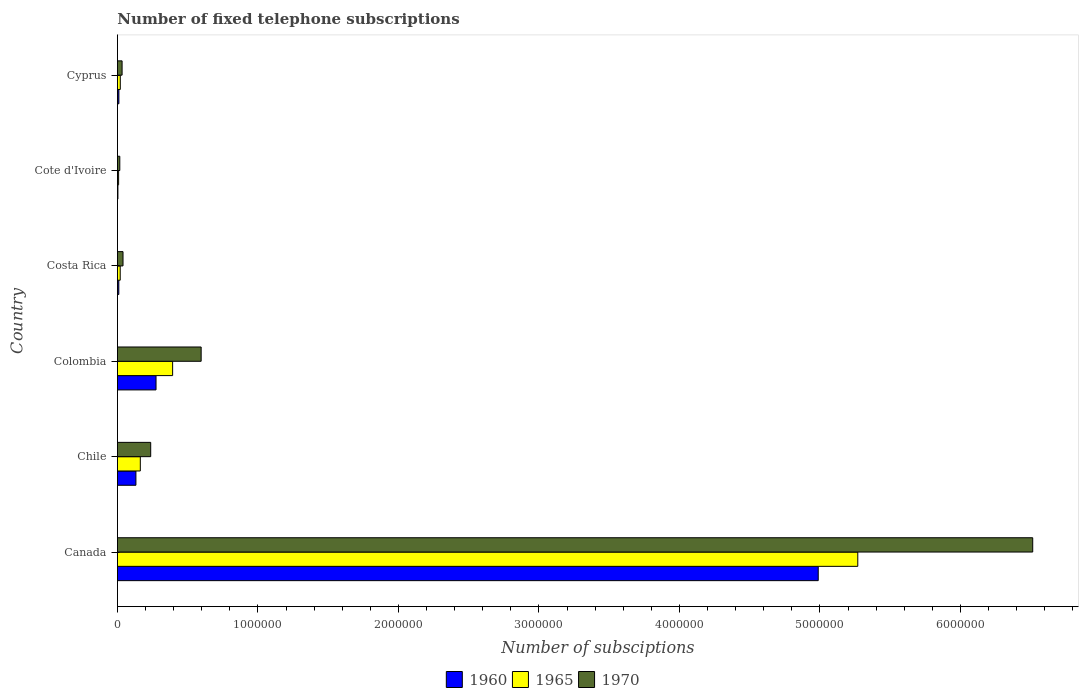How many different coloured bars are there?
Keep it short and to the point. 3. Are the number of bars per tick equal to the number of legend labels?
Keep it short and to the point. Yes. Are the number of bars on each tick of the Y-axis equal?
Your answer should be compact. Yes. In how many cases, is the number of bars for a given country not equal to the number of legend labels?
Your answer should be compact. 0. What is the number of fixed telephone subscriptions in 1965 in Colombia?
Provide a succinct answer. 3.93e+05. Across all countries, what is the maximum number of fixed telephone subscriptions in 1960?
Offer a very short reply. 4.99e+06. Across all countries, what is the minimum number of fixed telephone subscriptions in 1960?
Offer a very short reply. 3690. In which country was the number of fixed telephone subscriptions in 1960 maximum?
Your answer should be very brief. Canada. In which country was the number of fixed telephone subscriptions in 1960 minimum?
Provide a short and direct response. Cote d'Ivoire. What is the total number of fixed telephone subscriptions in 1970 in the graph?
Give a very brief answer. 7.44e+06. What is the difference between the number of fixed telephone subscriptions in 1970 in Costa Rica and that in Cyprus?
Offer a very short reply. 6641. What is the difference between the number of fixed telephone subscriptions in 1960 in Canada and the number of fixed telephone subscriptions in 1965 in Chile?
Make the answer very short. 4.82e+06. What is the average number of fixed telephone subscriptions in 1965 per country?
Offer a terse response. 9.79e+05. What is the difference between the number of fixed telephone subscriptions in 1965 and number of fixed telephone subscriptions in 1960 in Chile?
Offer a terse response. 3.12e+04. In how many countries, is the number of fixed telephone subscriptions in 1970 greater than 2400000 ?
Offer a terse response. 1. What is the ratio of the number of fixed telephone subscriptions in 1970 in Chile to that in Colombia?
Your response must be concise. 0.4. Is the difference between the number of fixed telephone subscriptions in 1965 in Canada and Cyprus greater than the difference between the number of fixed telephone subscriptions in 1960 in Canada and Cyprus?
Ensure brevity in your answer.  Yes. What is the difference between the highest and the second highest number of fixed telephone subscriptions in 1970?
Provide a succinct answer. 5.92e+06. What is the difference between the highest and the lowest number of fixed telephone subscriptions in 1970?
Ensure brevity in your answer.  6.50e+06. What does the 2nd bar from the top in Cote d'Ivoire represents?
Your answer should be very brief. 1965. How many bars are there?
Offer a terse response. 18. Are all the bars in the graph horizontal?
Give a very brief answer. Yes. How many countries are there in the graph?
Offer a terse response. 6. What is the difference between two consecutive major ticks on the X-axis?
Ensure brevity in your answer.  1.00e+06. Are the values on the major ticks of X-axis written in scientific E-notation?
Your response must be concise. No. Does the graph contain any zero values?
Keep it short and to the point. No. How many legend labels are there?
Offer a very short reply. 3. How are the legend labels stacked?
Your answer should be very brief. Horizontal. What is the title of the graph?
Provide a short and direct response. Number of fixed telephone subscriptions. Does "2012" appear as one of the legend labels in the graph?
Make the answer very short. No. What is the label or title of the X-axis?
Your response must be concise. Number of subsciptions. What is the label or title of the Y-axis?
Offer a terse response. Country. What is the Number of subsciptions of 1960 in Canada?
Ensure brevity in your answer.  4.99e+06. What is the Number of subsciptions of 1965 in Canada?
Keep it short and to the point. 5.27e+06. What is the Number of subsciptions in 1970 in Canada?
Offer a terse response. 6.51e+06. What is the Number of subsciptions in 1960 in Chile?
Offer a very short reply. 1.32e+05. What is the Number of subsciptions in 1965 in Chile?
Provide a succinct answer. 1.63e+05. What is the Number of subsciptions in 1970 in Chile?
Provide a succinct answer. 2.37e+05. What is the Number of subsciptions of 1960 in Colombia?
Offer a terse response. 2.75e+05. What is the Number of subsciptions of 1965 in Colombia?
Keep it short and to the point. 3.93e+05. What is the Number of subsciptions in 1970 in Colombia?
Offer a terse response. 5.96e+05. What is the Number of subsciptions of 1960 in Costa Rica?
Your answer should be very brief. 10000. What is the Number of subsciptions of 1970 in Costa Rica?
Give a very brief answer. 4.00e+04. What is the Number of subsciptions of 1960 in Cote d'Ivoire?
Make the answer very short. 3690. What is the Number of subsciptions in 1965 in Cote d'Ivoire?
Your answer should be compact. 8600. What is the Number of subsciptions in 1970 in Cote d'Ivoire?
Provide a short and direct response. 1.70e+04. What is the Number of subsciptions in 1960 in Cyprus?
Offer a terse response. 1.06e+04. What is the Number of subsciptions of 1965 in Cyprus?
Offer a terse response. 2.06e+04. What is the Number of subsciptions of 1970 in Cyprus?
Give a very brief answer. 3.34e+04. Across all countries, what is the maximum Number of subsciptions of 1960?
Offer a terse response. 4.99e+06. Across all countries, what is the maximum Number of subsciptions of 1965?
Ensure brevity in your answer.  5.27e+06. Across all countries, what is the maximum Number of subsciptions of 1970?
Your answer should be very brief. 6.51e+06. Across all countries, what is the minimum Number of subsciptions in 1960?
Keep it short and to the point. 3690. Across all countries, what is the minimum Number of subsciptions in 1965?
Offer a very short reply. 8600. Across all countries, what is the minimum Number of subsciptions of 1970?
Your answer should be very brief. 1.70e+04. What is the total Number of subsciptions in 1960 in the graph?
Your response must be concise. 5.42e+06. What is the total Number of subsciptions in 1965 in the graph?
Make the answer very short. 5.87e+06. What is the total Number of subsciptions of 1970 in the graph?
Offer a very short reply. 7.44e+06. What is the difference between the Number of subsciptions in 1960 in Canada and that in Chile?
Keep it short and to the point. 4.86e+06. What is the difference between the Number of subsciptions of 1965 in Canada and that in Chile?
Your answer should be very brief. 5.11e+06. What is the difference between the Number of subsciptions of 1970 in Canada and that in Chile?
Ensure brevity in your answer.  6.28e+06. What is the difference between the Number of subsciptions of 1960 in Canada and that in Colombia?
Offer a very short reply. 4.71e+06. What is the difference between the Number of subsciptions of 1965 in Canada and that in Colombia?
Ensure brevity in your answer.  4.88e+06. What is the difference between the Number of subsciptions in 1970 in Canada and that in Colombia?
Offer a very short reply. 5.92e+06. What is the difference between the Number of subsciptions in 1960 in Canada and that in Costa Rica?
Offer a terse response. 4.98e+06. What is the difference between the Number of subsciptions of 1965 in Canada and that in Costa Rica?
Give a very brief answer. 5.25e+06. What is the difference between the Number of subsciptions of 1970 in Canada and that in Costa Rica?
Make the answer very short. 6.47e+06. What is the difference between the Number of subsciptions of 1960 in Canada and that in Cote d'Ivoire?
Provide a succinct answer. 4.98e+06. What is the difference between the Number of subsciptions of 1965 in Canada and that in Cote d'Ivoire?
Give a very brief answer. 5.26e+06. What is the difference between the Number of subsciptions in 1970 in Canada and that in Cote d'Ivoire?
Your answer should be compact. 6.50e+06. What is the difference between the Number of subsciptions of 1960 in Canada and that in Cyprus?
Ensure brevity in your answer.  4.98e+06. What is the difference between the Number of subsciptions of 1965 in Canada and that in Cyprus?
Your answer should be very brief. 5.25e+06. What is the difference between the Number of subsciptions in 1970 in Canada and that in Cyprus?
Your response must be concise. 6.48e+06. What is the difference between the Number of subsciptions of 1960 in Chile and that in Colombia?
Your answer should be very brief. -1.43e+05. What is the difference between the Number of subsciptions of 1970 in Chile and that in Colombia?
Make the answer very short. -3.59e+05. What is the difference between the Number of subsciptions of 1960 in Chile and that in Costa Rica?
Offer a terse response. 1.22e+05. What is the difference between the Number of subsciptions in 1965 in Chile and that in Costa Rica?
Give a very brief answer. 1.43e+05. What is the difference between the Number of subsciptions of 1970 in Chile and that in Costa Rica?
Provide a short and direct response. 1.97e+05. What is the difference between the Number of subsciptions of 1960 in Chile and that in Cote d'Ivoire?
Provide a succinct answer. 1.28e+05. What is the difference between the Number of subsciptions in 1965 in Chile and that in Cote d'Ivoire?
Keep it short and to the point. 1.54e+05. What is the difference between the Number of subsciptions in 1970 in Chile and that in Cote d'Ivoire?
Provide a short and direct response. 2.20e+05. What is the difference between the Number of subsciptions of 1960 in Chile and that in Cyprus?
Keep it short and to the point. 1.21e+05. What is the difference between the Number of subsciptions in 1965 in Chile and that in Cyprus?
Provide a succinct answer. 1.42e+05. What is the difference between the Number of subsciptions of 1970 in Chile and that in Cyprus?
Give a very brief answer. 2.04e+05. What is the difference between the Number of subsciptions of 1960 in Colombia and that in Costa Rica?
Your answer should be compact. 2.65e+05. What is the difference between the Number of subsciptions of 1965 in Colombia and that in Costa Rica?
Ensure brevity in your answer.  3.73e+05. What is the difference between the Number of subsciptions in 1970 in Colombia and that in Costa Rica?
Offer a very short reply. 5.56e+05. What is the difference between the Number of subsciptions in 1960 in Colombia and that in Cote d'Ivoire?
Your answer should be very brief. 2.71e+05. What is the difference between the Number of subsciptions of 1965 in Colombia and that in Cote d'Ivoire?
Give a very brief answer. 3.84e+05. What is the difference between the Number of subsciptions in 1970 in Colombia and that in Cote d'Ivoire?
Offer a terse response. 5.79e+05. What is the difference between the Number of subsciptions in 1960 in Colombia and that in Cyprus?
Your answer should be very brief. 2.64e+05. What is the difference between the Number of subsciptions of 1965 in Colombia and that in Cyprus?
Offer a terse response. 3.72e+05. What is the difference between the Number of subsciptions of 1970 in Colombia and that in Cyprus?
Your response must be concise. 5.63e+05. What is the difference between the Number of subsciptions in 1960 in Costa Rica and that in Cote d'Ivoire?
Keep it short and to the point. 6310. What is the difference between the Number of subsciptions in 1965 in Costa Rica and that in Cote d'Ivoire?
Your answer should be very brief. 1.14e+04. What is the difference between the Number of subsciptions in 1970 in Costa Rica and that in Cote d'Ivoire?
Provide a succinct answer. 2.30e+04. What is the difference between the Number of subsciptions of 1960 in Costa Rica and that in Cyprus?
Provide a short and direct response. -630. What is the difference between the Number of subsciptions of 1965 in Costa Rica and that in Cyprus?
Give a very brief answer. -550. What is the difference between the Number of subsciptions in 1970 in Costa Rica and that in Cyprus?
Offer a very short reply. 6641. What is the difference between the Number of subsciptions of 1960 in Cote d'Ivoire and that in Cyprus?
Your answer should be very brief. -6940. What is the difference between the Number of subsciptions in 1965 in Cote d'Ivoire and that in Cyprus?
Offer a terse response. -1.20e+04. What is the difference between the Number of subsciptions in 1970 in Cote d'Ivoire and that in Cyprus?
Your answer should be very brief. -1.64e+04. What is the difference between the Number of subsciptions in 1960 in Canada and the Number of subsciptions in 1965 in Chile?
Provide a short and direct response. 4.82e+06. What is the difference between the Number of subsciptions in 1960 in Canada and the Number of subsciptions in 1970 in Chile?
Ensure brevity in your answer.  4.75e+06. What is the difference between the Number of subsciptions in 1965 in Canada and the Number of subsciptions in 1970 in Chile?
Provide a succinct answer. 5.03e+06. What is the difference between the Number of subsciptions of 1960 in Canada and the Number of subsciptions of 1965 in Colombia?
Your response must be concise. 4.59e+06. What is the difference between the Number of subsciptions in 1960 in Canada and the Number of subsciptions in 1970 in Colombia?
Provide a short and direct response. 4.39e+06. What is the difference between the Number of subsciptions in 1965 in Canada and the Number of subsciptions in 1970 in Colombia?
Make the answer very short. 4.67e+06. What is the difference between the Number of subsciptions of 1960 in Canada and the Number of subsciptions of 1965 in Costa Rica?
Ensure brevity in your answer.  4.97e+06. What is the difference between the Number of subsciptions of 1960 in Canada and the Number of subsciptions of 1970 in Costa Rica?
Ensure brevity in your answer.  4.95e+06. What is the difference between the Number of subsciptions in 1965 in Canada and the Number of subsciptions in 1970 in Costa Rica?
Make the answer very short. 5.23e+06. What is the difference between the Number of subsciptions of 1960 in Canada and the Number of subsciptions of 1965 in Cote d'Ivoire?
Keep it short and to the point. 4.98e+06. What is the difference between the Number of subsciptions of 1960 in Canada and the Number of subsciptions of 1970 in Cote d'Ivoire?
Provide a short and direct response. 4.97e+06. What is the difference between the Number of subsciptions of 1965 in Canada and the Number of subsciptions of 1970 in Cote d'Ivoire?
Provide a succinct answer. 5.25e+06. What is the difference between the Number of subsciptions of 1960 in Canada and the Number of subsciptions of 1965 in Cyprus?
Provide a short and direct response. 4.97e+06. What is the difference between the Number of subsciptions of 1960 in Canada and the Number of subsciptions of 1970 in Cyprus?
Provide a short and direct response. 4.95e+06. What is the difference between the Number of subsciptions in 1965 in Canada and the Number of subsciptions in 1970 in Cyprus?
Make the answer very short. 5.24e+06. What is the difference between the Number of subsciptions of 1960 in Chile and the Number of subsciptions of 1965 in Colombia?
Keep it short and to the point. -2.61e+05. What is the difference between the Number of subsciptions in 1960 in Chile and the Number of subsciptions in 1970 in Colombia?
Give a very brief answer. -4.64e+05. What is the difference between the Number of subsciptions of 1965 in Chile and the Number of subsciptions of 1970 in Colombia?
Provide a succinct answer. -4.33e+05. What is the difference between the Number of subsciptions of 1960 in Chile and the Number of subsciptions of 1965 in Costa Rica?
Ensure brevity in your answer.  1.12e+05. What is the difference between the Number of subsciptions of 1960 in Chile and the Number of subsciptions of 1970 in Costa Rica?
Your response must be concise. 9.18e+04. What is the difference between the Number of subsciptions of 1965 in Chile and the Number of subsciptions of 1970 in Costa Rica?
Offer a very short reply. 1.23e+05. What is the difference between the Number of subsciptions of 1960 in Chile and the Number of subsciptions of 1965 in Cote d'Ivoire?
Provide a succinct answer. 1.23e+05. What is the difference between the Number of subsciptions of 1960 in Chile and the Number of subsciptions of 1970 in Cote d'Ivoire?
Provide a succinct answer. 1.15e+05. What is the difference between the Number of subsciptions in 1965 in Chile and the Number of subsciptions in 1970 in Cote d'Ivoire?
Your answer should be compact. 1.46e+05. What is the difference between the Number of subsciptions of 1960 in Chile and the Number of subsciptions of 1965 in Cyprus?
Your response must be concise. 1.11e+05. What is the difference between the Number of subsciptions in 1960 in Chile and the Number of subsciptions in 1970 in Cyprus?
Provide a short and direct response. 9.84e+04. What is the difference between the Number of subsciptions in 1965 in Chile and the Number of subsciptions in 1970 in Cyprus?
Ensure brevity in your answer.  1.30e+05. What is the difference between the Number of subsciptions in 1960 in Colombia and the Number of subsciptions in 1965 in Costa Rica?
Offer a terse response. 2.55e+05. What is the difference between the Number of subsciptions in 1960 in Colombia and the Number of subsciptions in 1970 in Costa Rica?
Provide a short and direct response. 2.35e+05. What is the difference between the Number of subsciptions in 1965 in Colombia and the Number of subsciptions in 1970 in Costa Rica?
Make the answer very short. 3.53e+05. What is the difference between the Number of subsciptions of 1960 in Colombia and the Number of subsciptions of 1965 in Cote d'Ivoire?
Give a very brief answer. 2.66e+05. What is the difference between the Number of subsciptions of 1960 in Colombia and the Number of subsciptions of 1970 in Cote d'Ivoire?
Offer a terse response. 2.58e+05. What is the difference between the Number of subsciptions in 1965 in Colombia and the Number of subsciptions in 1970 in Cote d'Ivoire?
Provide a short and direct response. 3.76e+05. What is the difference between the Number of subsciptions in 1960 in Colombia and the Number of subsciptions in 1965 in Cyprus?
Offer a terse response. 2.54e+05. What is the difference between the Number of subsciptions of 1960 in Colombia and the Number of subsciptions of 1970 in Cyprus?
Offer a very short reply. 2.42e+05. What is the difference between the Number of subsciptions in 1965 in Colombia and the Number of subsciptions in 1970 in Cyprus?
Offer a very short reply. 3.60e+05. What is the difference between the Number of subsciptions of 1960 in Costa Rica and the Number of subsciptions of 1965 in Cote d'Ivoire?
Your response must be concise. 1400. What is the difference between the Number of subsciptions of 1960 in Costa Rica and the Number of subsciptions of 1970 in Cote d'Ivoire?
Your answer should be compact. -7000. What is the difference between the Number of subsciptions of 1965 in Costa Rica and the Number of subsciptions of 1970 in Cote d'Ivoire?
Your answer should be compact. 3000. What is the difference between the Number of subsciptions in 1960 in Costa Rica and the Number of subsciptions in 1965 in Cyprus?
Make the answer very short. -1.06e+04. What is the difference between the Number of subsciptions of 1960 in Costa Rica and the Number of subsciptions of 1970 in Cyprus?
Offer a very short reply. -2.34e+04. What is the difference between the Number of subsciptions in 1965 in Costa Rica and the Number of subsciptions in 1970 in Cyprus?
Your response must be concise. -1.34e+04. What is the difference between the Number of subsciptions of 1960 in Cote d'Ivoire and the Number of subsciptions of 1965 in Cyprus?
Provide a short and direct response. -1.69e+04. What is the difference between the Number of subsciptions in 1960 in Cote d'Ivoire and the Number of subsciptions in 1970 in Cyprus?
Your answer should be very brief. -2.97e+04. What is the difference between the Number of subsciptions in 1965 in Cote d'Ivoire and the Number of subsciptions in 1970 in Cyprus?
Offer a terse response. -2.48e+04. What is the average Number of subsciptions of 1960 per country?
Give a very brief answer. 9.03e+05. What is the average Number of subsciptions of 1965 per country?
Offer a terse response. 9.79e+05. What is the average Number of subsciptions of 1970 per country?
Make the answer very short. 1.24e+06. What is the difference between the Number of subsciptions of 1960 and Number of subsciptions of 1965 in Canada?
Make the answer very short. -2.81e+05. What is the difference between the Number of subsciptions of 1960 and Number of subsciptions of 1970 in Canada?
Offer a very short reply. -1.53e+06. What is the difference between the Number of subsciptions of 1965 and Number of subsciptions of 1970 in Canada?
Your response must be concise. -1.24e+06. What is the difference between the Number of subsciptions of 1960 and Number of subsciptions of 1965 in Chile?
Your answer should be very brief. -3.12e+04. What is the difference between the Number of subsciptions of 1960 and Number of subsciptions of 1970 in Chile?
Make the answer very short. -1.05e+05. What is the difference between the Number of subsciptions of 1965 and Number of subsciptions of 1970 in Chile?
Keep it short and to the point. -7.40e+04. What is the difference between the Number of subsciptions of 1960 and Number of subsciptions of 1965 in Colombia?
Make the answer very short. -1.18e+05. What is the difference between the Number of subsciptions of 1960 and Number of subsciptions of 1970 in Colombia?
Your answer should be compact. -3.21e+05. What is the difference between the Number of subsciptions of 1965 and Number of subsciptions of 1970 in Colombia?
Offer a terse response. -2.03e+05. What is the difference between the Number of subsciptions of 1960 and Number of subsciptions of 1965 in Costa Rica?
Make the answer very short. -10000. What is the difference between the Number of subsciptions of 1965 and Number of subsciptions of 1970 in Costa Rica?
Keep it short and to the point. -2.00e+04. What is the difference between the Number of subsciptions of 1960 and Number of subsciptions of 1965 in Cote d'Ivoire?
Provide a succinct answer. -4910. What is the difference between the Number of subsciptions in 1960 and Number of subsciptions in 1970 in Cote d'Ivoire?
Provide a succinct answer. -1.33e+04. What is the difference between the Number of subsciptions in 1965 and Number of subsciptions in 1970 in Cote d'Ivoire?
Offer a very short reply. -8400. What is the difference between the Number of subsciptions of 1960 and Number of subsciptions of 1965 in Cyprus?
Offer a terse response. -9920. What is the difference between the Number of subsciptions of 1960 and Number of subsciptions of 1970 in Cyprus?
Make the answer very short. -2.27e+04. What is the difference between the Number of subsciptions in 1965 and Number of subsciptions in 1970 in Cyprus?
Your answer should be very brief. -1.28e+04. What is the ratio of the Number of subsciptions in 1960 in Canada to that in Chile?
Keep it short and to the point. 37.84. What is the ratio of the Number of subsciptions of 1965 in Canada to that in Chile?
Ensure brevity in your answer.  32.33. What is the ratio of the Number of subsciptions of 1970 in Canada to that in Chile?
Your answer should be very brief. 27.49. What is the ratio of the Number of subsciptions of 1960 in Canada to that in Colombia?
Your answer should be very brief. 18.14. What is the ratio of the Number of subsciptions in 1965 in Canada to that in Colombia?
Keep it short and to the point. 13.41. What is the ratio of the Number of subsciptions in 1970 in Canada to that in Colombia?
Provide a succinct answer. 10.93. What is the ratio of the Number of subsciptions of 1960 in Canada to that in Costa Rica?
Your response must be concise. 498.75. What is the ratio of the Number of subsciptions in 1965 in Canada to that in Costa Rica?
Ensure brevity in your answer.  263.45. What is the ratio of the Number of subsciptions of 1970 in Canada to that in Costa Rica?
Keep it short and to the point. 162.85. What is the ratio of the Number of subsciptions in 1960 in Canada to that in Cote d'Ivoire?
Your answer should be very brief. 1351.63. What is the ratio of the Number of subsciptions of 1965 in Canada to that in Cote d'Ivoire?
Your answer should be compact. 612.67. What is the ratio of the Number of subsciptions of 1970 in Canada to that in Cote d'Ivoire?
Provide a succinct answer. 383.18. What is the ratio of the Number of subsciptions in 1960 in Canada to that in Cyprus?
Keep it short and to the point. 469.19. What is the ratio of the Number of subsciptions of 1965 in Canada to that in Cyprus?
Your response must be concise. 256.4. What is the ratio of the Number of subsciptions in 1970 in Canada to that in Cyprus?
Make the answer very short. 195.27. What is the ratio of the Number of subsciptions of 1960 in Chile to that in Colombia?
Your response must be concise. 0.48. What is the ratio of the Number of subsciptions of 1965 in Chile to that in Colombia?
Keep it short and to the point. 0.41. What is the ratio of the Number of subsciptions of 1970 in Chile to that in Colombia?
Give a very brief answer. 0.4. What is the ratio of the Number of subsciptions in 1960 in Chile to that in Costa Rica?
Your answer should be compact. 13.18. What is the ratio of the Number of subsciptions in 1965 in Chile to that in Costa Rica?
Offer a terse response. 8.15. What is the ratio of the Number of subsciptions in 1970 in Chile to that in Costa Rica?
Ensure brevity in your answer.  5.92. What is the ratio of the Number of subsciptions in 1960 in Chile to that in Cote d'Ivoire?
Your response must be concise. 35.72. What is the ratio of the Number of subsciptions of 1965 in Chile to that in Cote d'Ivoire?
Provide a succinct answer. 18.95. What is the ratio of the Number of subsciptions in 1970 in Chile to that in Cote d'Ivoire?
Offer a terse response. 13.94. What is the ratio of the Number of subsciptions in 1960 in Chile to that in Cyprus?
Give a very brief answer. 12.4. What is the ratio of the Number of subsciptions in 1965 in Chile to that in Cyprus?
Make the answer very short. 7.93. What is the ratio of the Number of subsciptions in 1970 in Chile to that in Cyprus?
Your answer should be compact. 7.1. What is the ratio of the Number of subsciptions in 1960 in Colombia to that in Costa Rica?
Keep it short and to the point. 27.49. What is the ratio of the Number of subsciptions of 1965 in Colombia to that in Costa Rica?
Provide a short and direct response. 19.65. What is the ratio of the Number of subsciptions of 1970 in Colombia to that in Costa Rica?
Your answer should be compact. 14.9. What is the ratio of the Number of subsciptions in 1960 in Colombia to that in Cote d'Ivoire?
Your answer should be compact. 74.51. What is the ratio of the Number of subsciptions of 1965 in Colombia to that in Cote d'Ivoire?
Your answer should be very brief. 45.7. What is the ratio of the Number of subsciptions in 1970 in Colombia to that in Cote d'Ivoire?
Provide a short and direct response. 35.06. What is the ratio of the Number of subsciptions in 1960 in Colombia to that in Cyprus?
Keep it short and to the point. 25.86. What is the ratio of the Number of subsciptions of 1965 in Colombia to that in Cyprus?
Provide a succinct answer. 19.12. What is the ratio of the Number of subsciptions in 1970 in Colombia to that in Cyprus?
Your response must be concise. 17.87. What is the ratio of the Number of subsciptions of 1960 in Costa Rica to that in Cote d'Ivoire?
Offer a terse response. 2.71. What is the ratio of the Number of subsciptions in 1965 in Costa Rica to that in Cote d'Ivoire?
Your answer should be compact. 2.33. What is the ratio of the Number of subsciptions in 1970 in Costa Rica to that in Cote d'Ivoire?
Provide a succinct answer. 2.35. What is the ratio of the Number of subsciptions in 1960 in Costa Rica to that in Cyprus?
Provide a succinct answer. 0.94. What is the ratio of the Number of subsciptions in 1965 in Costa Rica to that in Cyprus?
Ensure brevity in your answer.  0.97. What is the ratio of the Number of subsciptions of 1970 in Costa Rica to that in Cyprus?
Your answer should be very brief. 1.2. What is the ratio of the Number of subsciptions in 1960 in Cote d'Ivoire to that in Cyprus?
Offer a terse response. 0.35. What is the ratio of the Number of subsciptions of 1965 in Cote d'Ivoire to that in Cyprus?
Your answer should be very brief. 0.42. What is the ratio of the Number of subsciptions of 1970 in Cote d'Ivoire to that in Cyprus?
Give a very brief answer. 0.51. What is the difference between the highest and the second highest Number of subsciptions of 1960?
Offer a terse response. 4.71e+06. What is the difference between the highest and the second highest Number of subsciptions in 1965?
Your response must be concise. 4.88e+06. What is the difference between the highest and the second highest Number of subsciptions in 1970?
Ensure brevity in your answer.  5.92e+06. What is the difference between the highest and the lowest Number of subsciptions in 1960?
Offer a very short reply. 4.98e+06. What is the difference between the highest and the lowest Number of subsciptions in 1965?
Make the answer very short. 5.26e+06. What is the difference between the highest and the lowest Number of subsciptions in 1970?
Provide a succinct answer. 6.50e+06. 